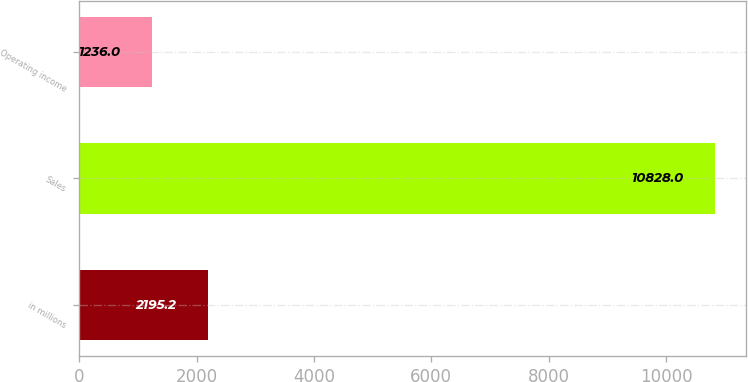<chart> <loc_0><loc_0><loc_500><loc_500><bar_chart><fcel>in millions<fcel>Sales<fcel>Operating income<nl><fcel>2195.2<fcel>10828<fcel>1236<nl></chart> 